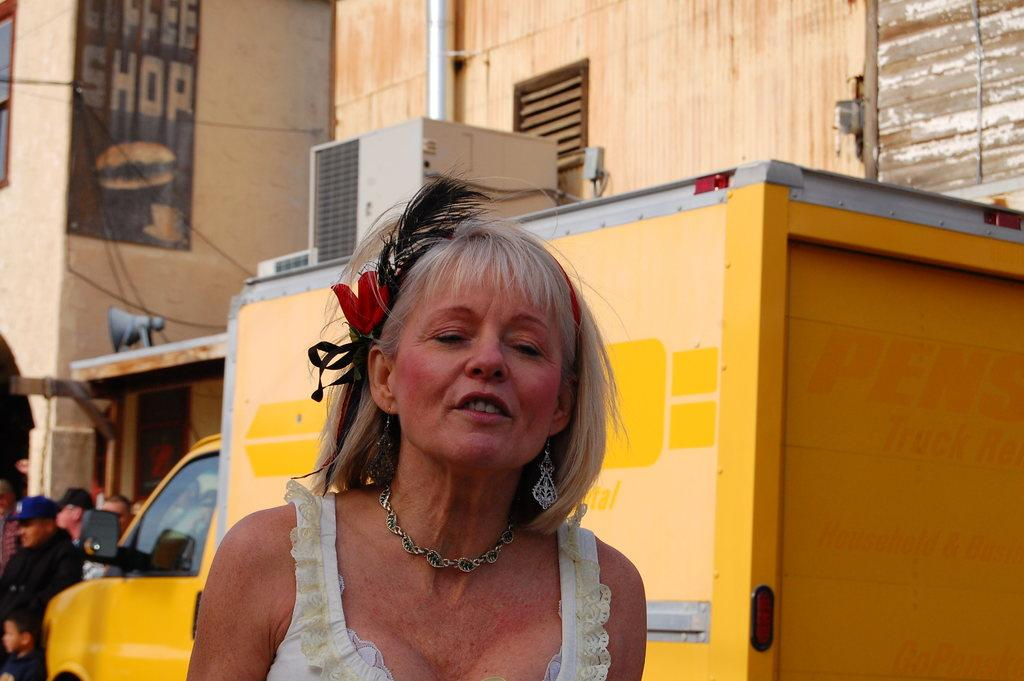Provide a one-sentence caption for the provided image. A woman with her eyes closed stands in front of a sign for a coffee shop. 